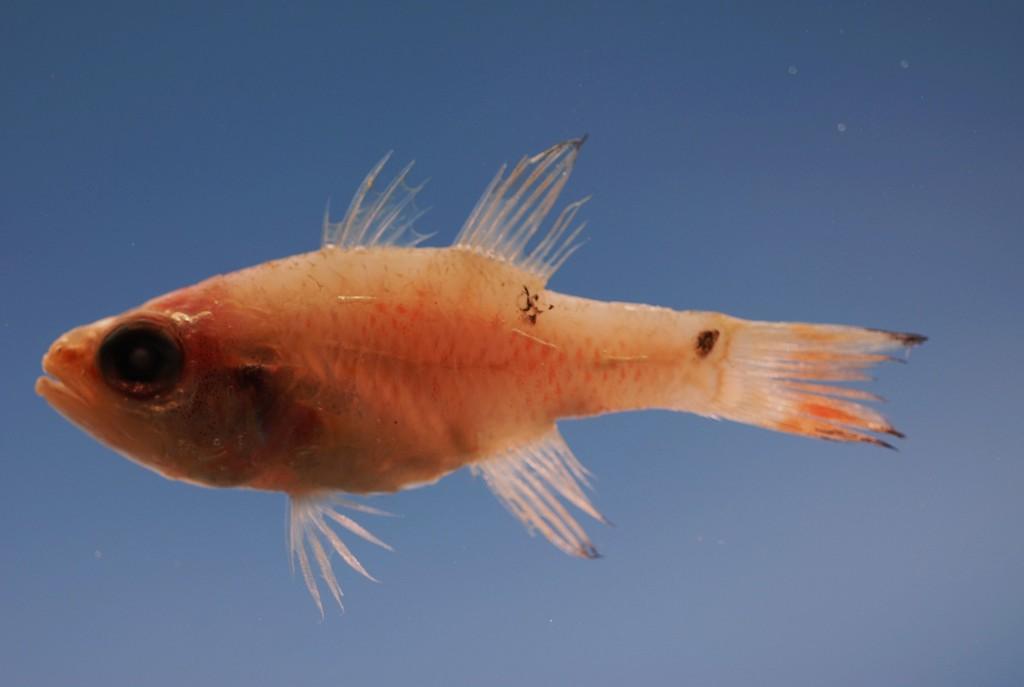How would you summarize this image in a sentence or two? This image consists of a fish in the water. This image is taken may be in the ocean. 